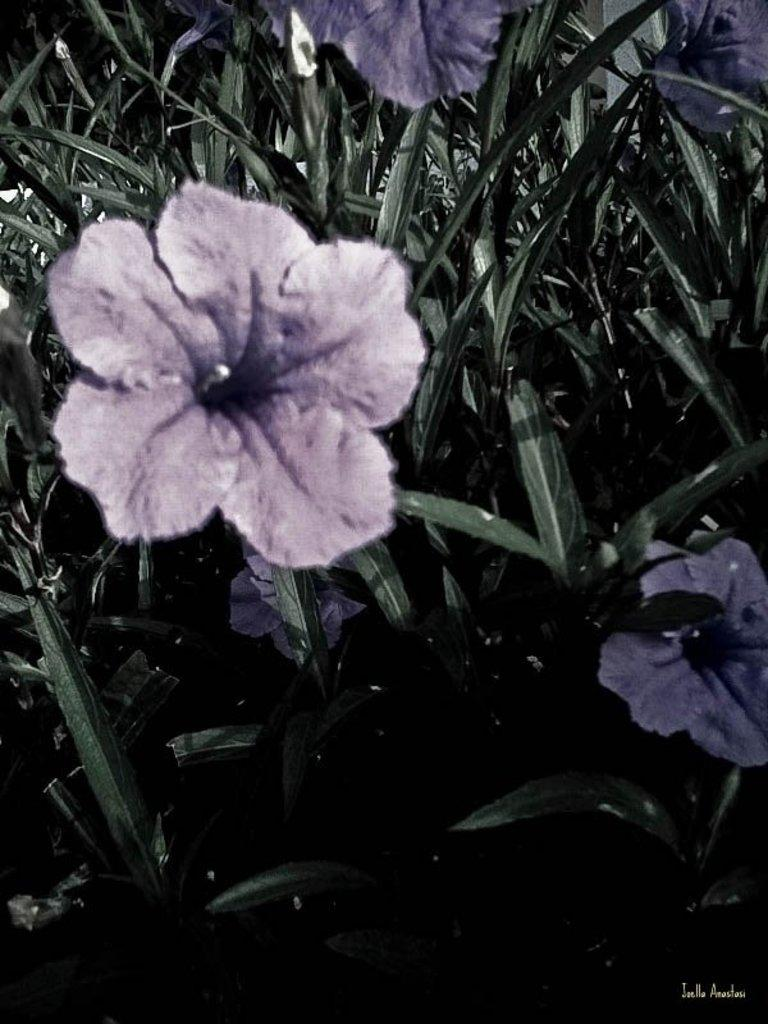What type of living organisms can be seen in the image? Plants can be seen in the image. Can you describe a specific flower in the image? There is a purple flower in the image. What part of the plants is visible in the image? Leaves are present in the image. What direction is the church facing in the image? There is no church present in the image, so it is not possible to determine the direction it might be facing. 